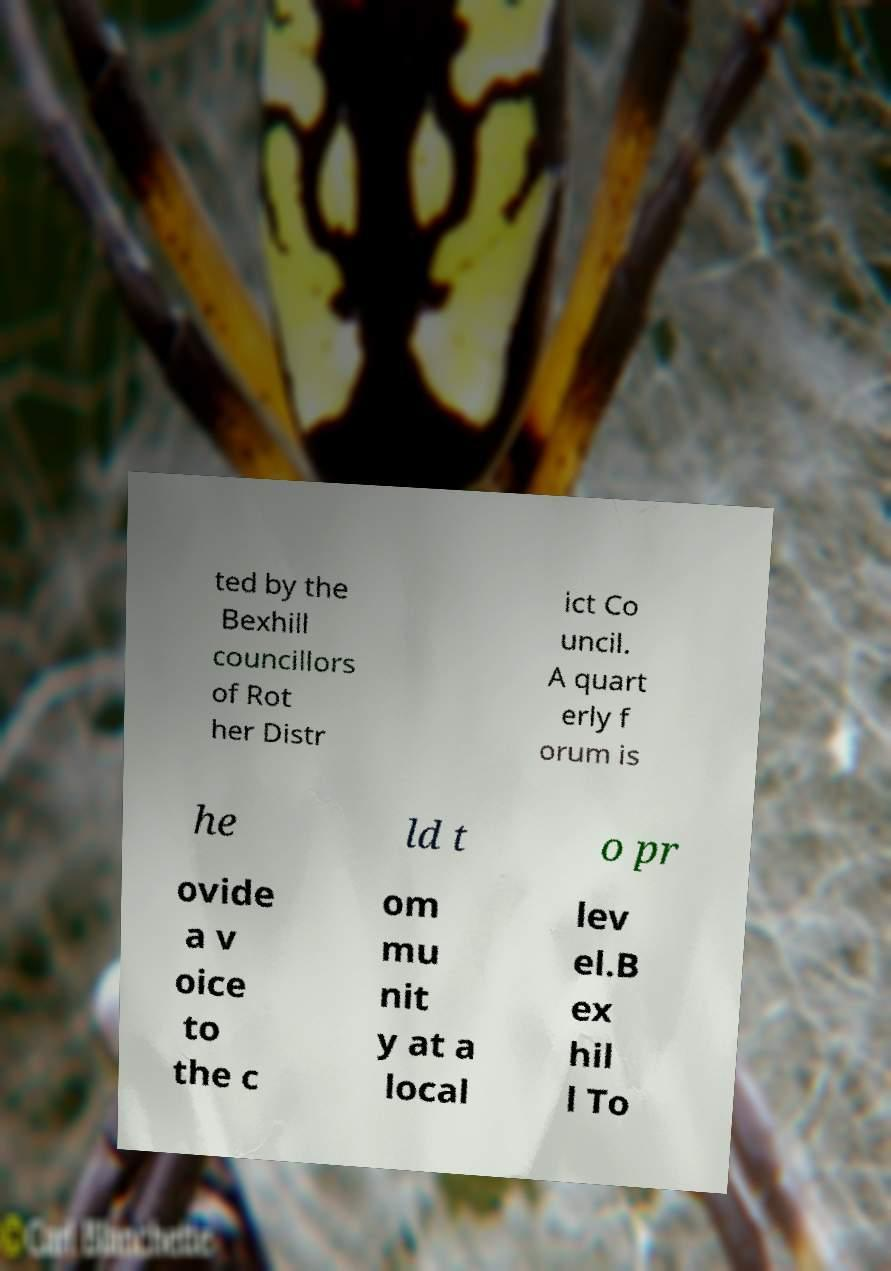I need the written content from this picture converted into text. Can you do that? ted by the Bexhill councillors of Rot her Distr ict Co uncil. A quart erly f orum is he ld t o pr ovide a v oice to the c om mu nit y at a local lev el.B ex hil l To 